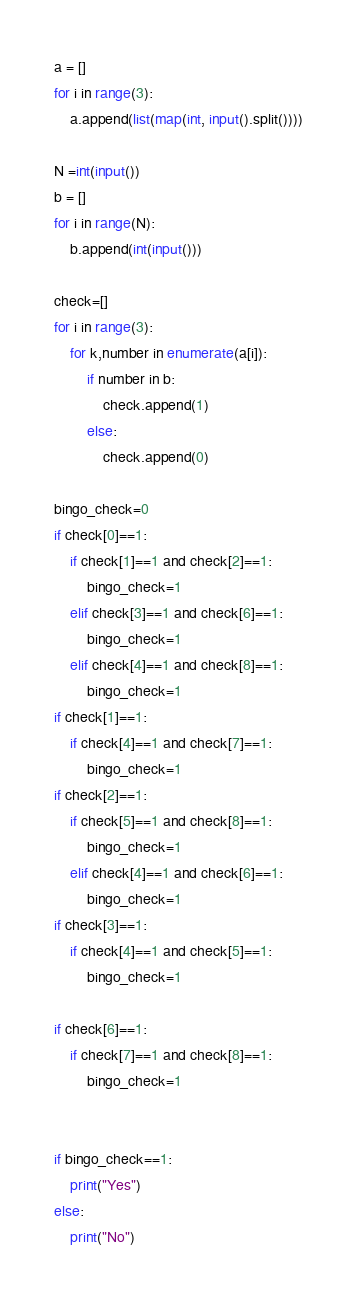Convert code to text. <code><loc_0><loc_0><loc_500><loc_500><_Python_>a = []
for i in range(3):
    a.append(list(map(int, input().split())))

N =int(input())
b = []
for i in range(N):
    b.append(int(input()))

check=[]
for i in range(3):
    for k,number in enumerate(a[i]):
        if number in b:
            check.append(1)
        else:
            check.append(0)

bingo_check=0
if check[0]==1:
    if check[1]==1 and check[2]==1:
        bingo_check=1
    elif check[3]==1 and check[6]==1:
        bingo_check=1
    elif check[4]==1 and check[8]==1:
        bingo_check=1
if check[1]==1:
    if check[4]==1 and check[7]==1:
        bingo_check=1
if check[2]==1:
    if check[5]==1 and check[8]==1:
        bingo_check=1
    elif check[4]==1 and check[6]==1:
        bingo_check=1
if check[3]==1:
    if check[4]==1 and check[5]==1:
        bingo_check=1

if check[6]==1:
    if check[7]==1 and check[8]==1:
        bingo_check=1


if bingo_check==1:
    print("Yes")
else:
    print("No")</code> 